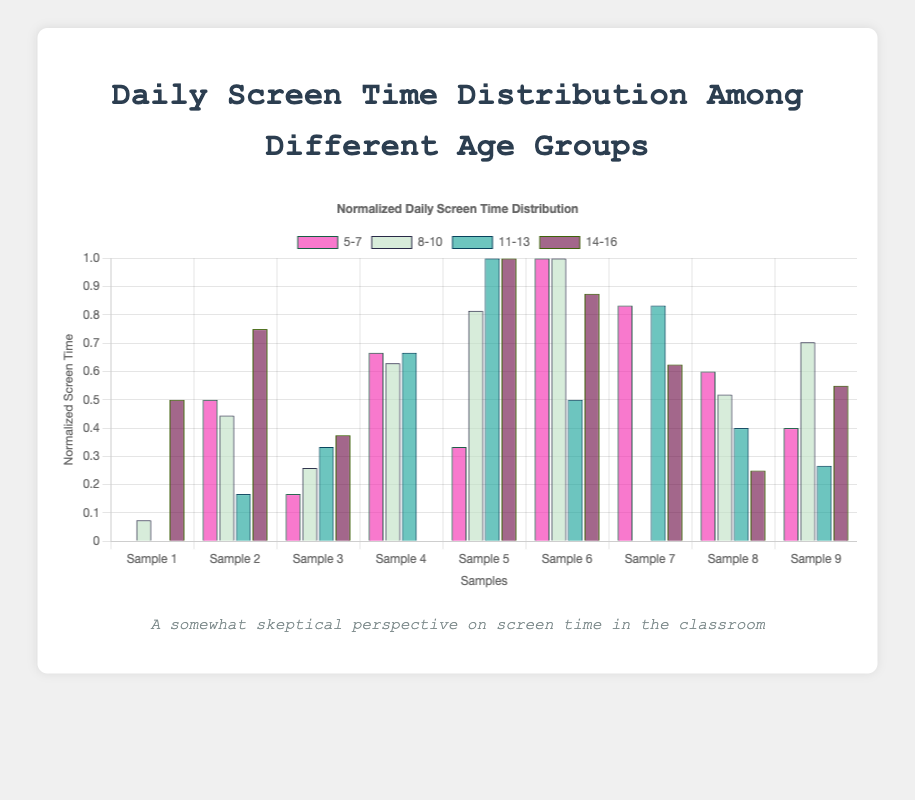What does the title of the chart say? The title is located at the top of the chart. It reads "Normalized Daily Screen Time Distribution".
Answer: "Normalized Daily Screen Time Distribution" Which age group has the highest bar in the chart? Looking at the chart and comparing the height of the bars, it is clear that the age group "14-16" has the highest bar.
Answer: "14-16" How many sample points are displayed for each age group? Each age group shows the same number of bars. By counting the bars for one age group, we see that there are 9 sample points.
Answer: 9 Which age group shows the most variation in their normalized screen time? The age group with the most variation will have the bars spread out more with different heights. "14-16" age group shows the highest variation based on the visual distance between its highest and lowest bars.
Answer: "14-16" What is the minimum and maximum value of the normalized screen time for the age group 8-10? For the age group 8-10, the minimum value (the shortest bar) is 0, and the maximum value (the tallest bar) is 1, as the data was normalized to a 0-1 range.
Answer: 0 and 1 Is there any age group that has an outlier in their screen time distribution? By scanning the chart for any significant deviation, the "14-16" age group has one bar that appears higher above the rest, indicating a possible outlier.
Answer: "14-16" What is the average normalized screen time for the age group 11-13? Sum the height of all bars for age group 11-13 and divide by the number of bars (9).
Answer: Average value is around 0.5 How does the normalized screen time distribution for the age group 5-7 compare to the 8-10 age group? Comparing visually, the age group 5-7 has lower and more uniform bars compared to the 8-10 age group, indicating less variation and generally lower values.
Answer: 5-7 is lower and less varied than 8-10 Which two age groups exhibit the closest mean normalized screen time? Calculate or visually estimate the average height of bars for each group. "11-13" and "8-10" exhibit similar average heights when compared visually.
Answer: "11-13" and "8-10" 